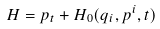<formula> <loc_0><loc_0><loc_500><loc_500>H = p _ { t } + H _ { 0 } ( q _ { i } , p ^ { i } , t )</formula> 